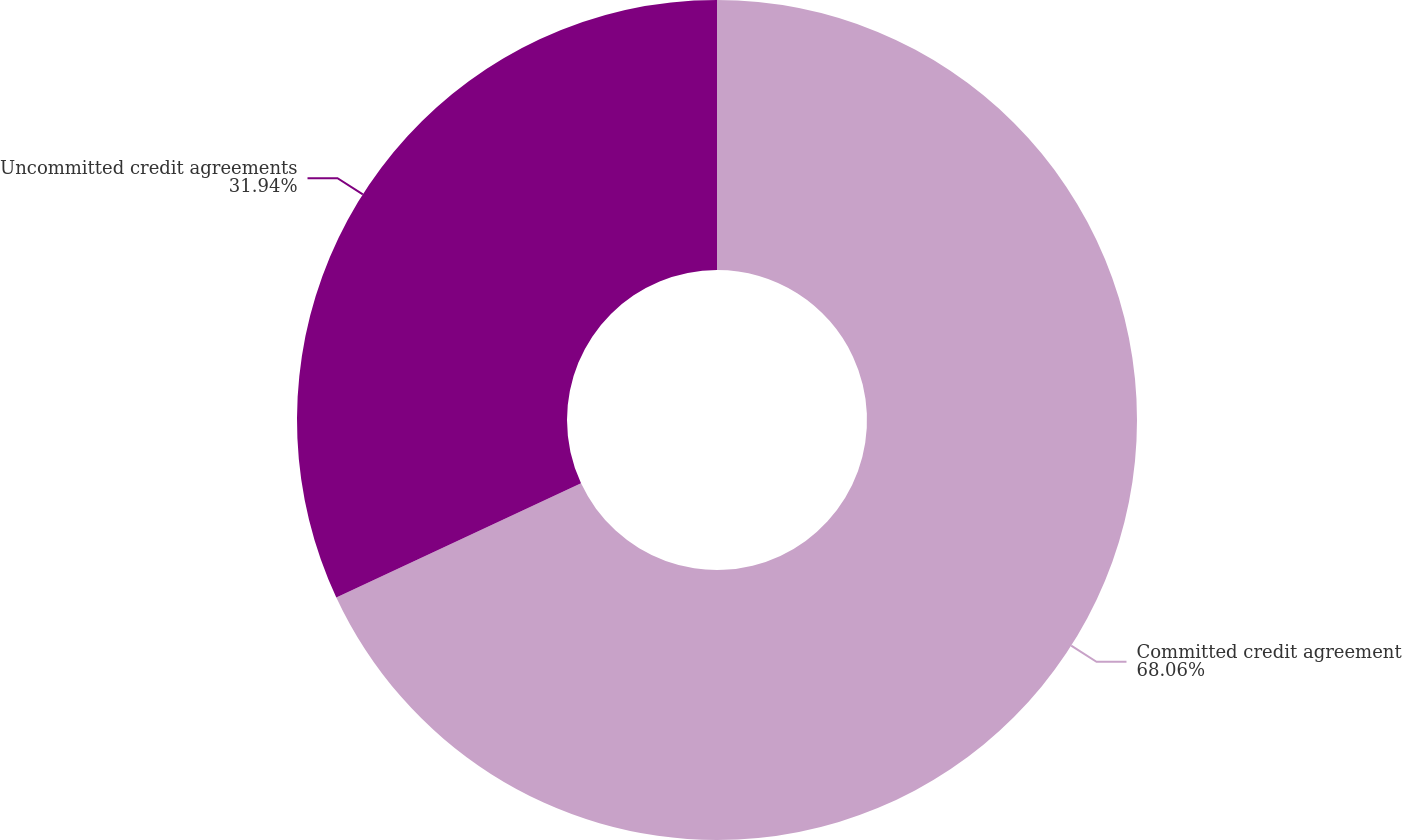Convert chart. <chart><loc_0><loc_0><loc_500><loc_500><pie_chart><fcel>Committed credit agreement<fcel>Uncommitted credit agreements<nl><fcel>68.06%<fcel>31.94%<nl></chart> 